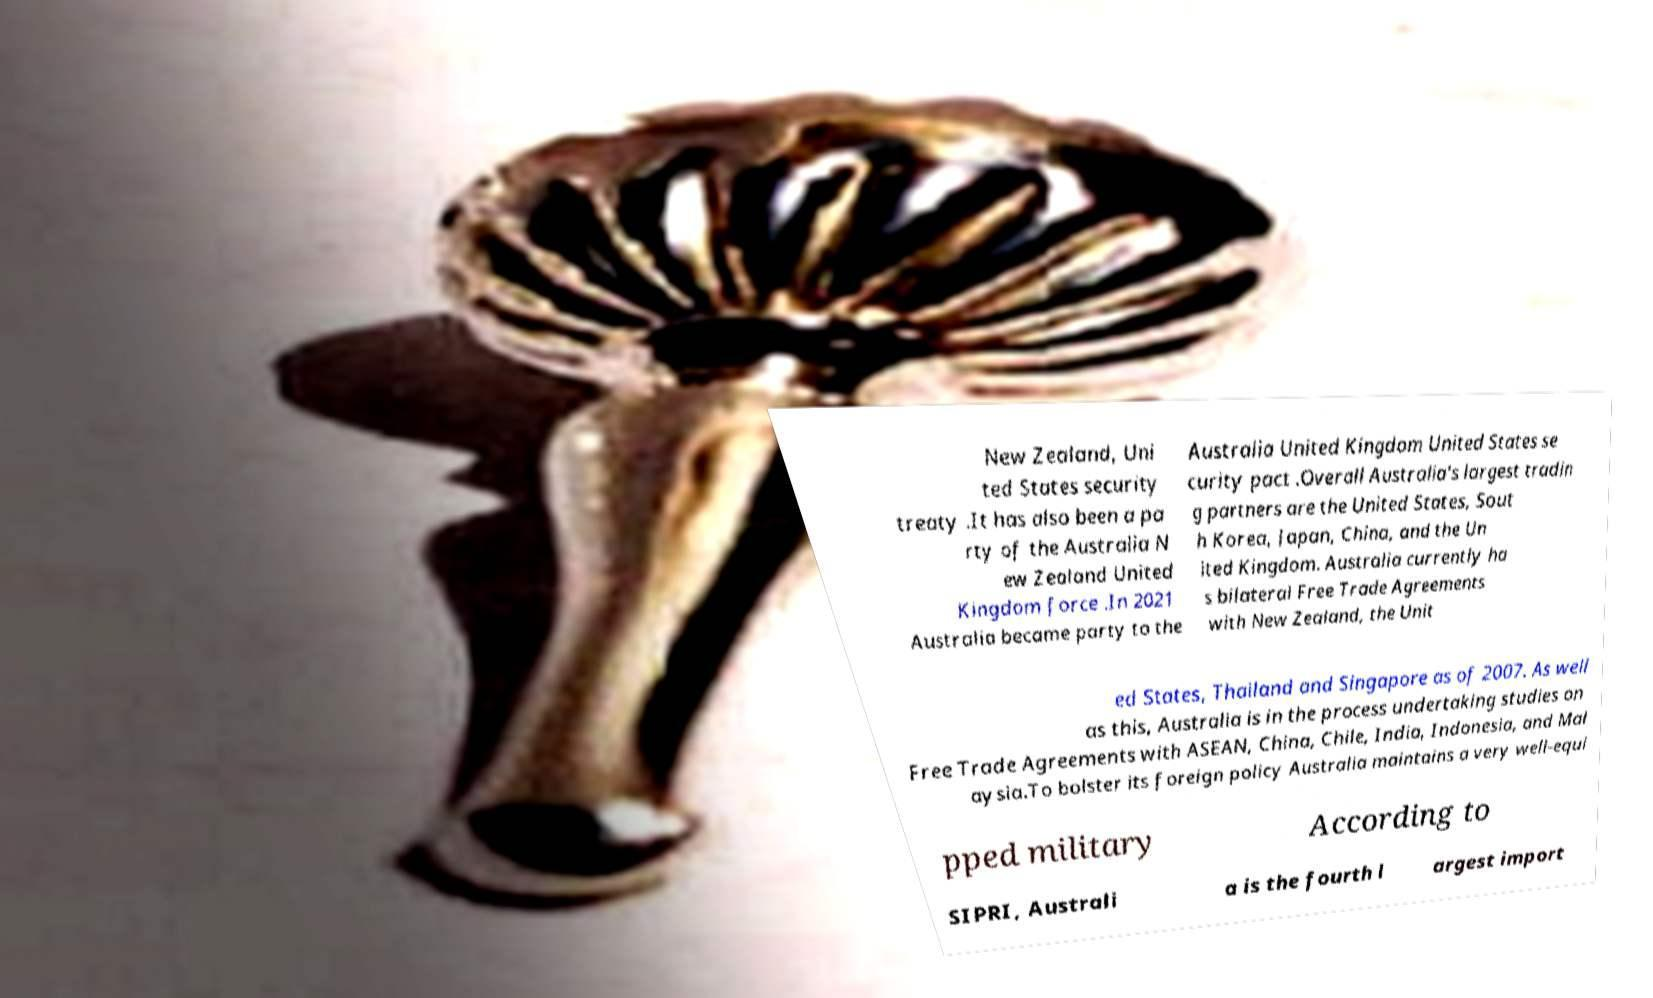Can you read and provide the text displayed in the image?This photo seems to have some interesting text. Can you extract and type it out for me? New Zealand, Uni ted States security treaty .It has also been a pa rty of the Australia N ew Zealand United Kingdom force .In 2021 Australia became party to the Australia United Kingdom United States se curity pact .Overall Australia's largest tradin g partners are the United States, Sout h Korea, Japan, China, and the Un ited Kingdom. Australia currently ha s bilateral Free Trade Agreements with New Zealand, the Unit ed States, Thailand and Singapore as of 2007. As well as this, Australia is in the process undertaking studies on Free Trade Agreements with ASEAN, China, Chile, India, Indonesia, and Mal aysia.To bolster its foreign policy Australia maintains a very well-equi pped military According to SIPRI, Australi a is the fourth l argest import 